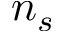Convert formula to latex. <formula><loc_0><loc_0><loc_500><loc_500>n _ { s }</formula> 